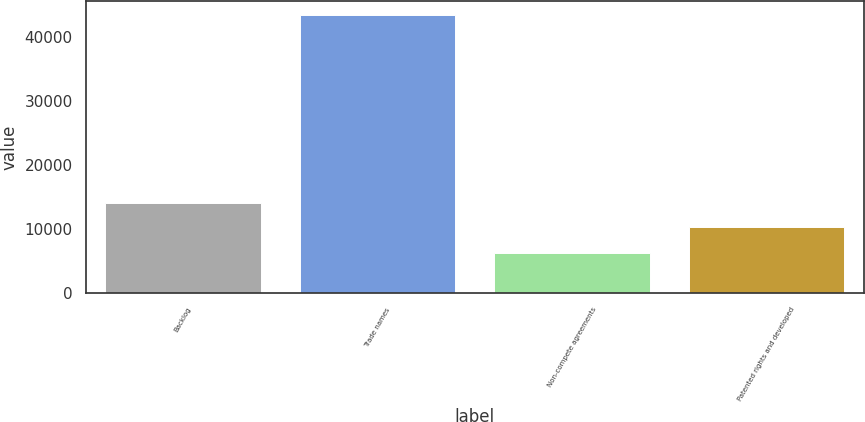Convert chart to OTSL. <chart><loc_0><loc_0><loc_500><loc_500><bar_chart><fcel>Backlog<fcel>Trade names<fcel>Non-compete agreements<fcel>Patented rights and developed<nl><fcel>14087.2<fcel>43386<fcel>6294<fcel>10378<nl></chart> 